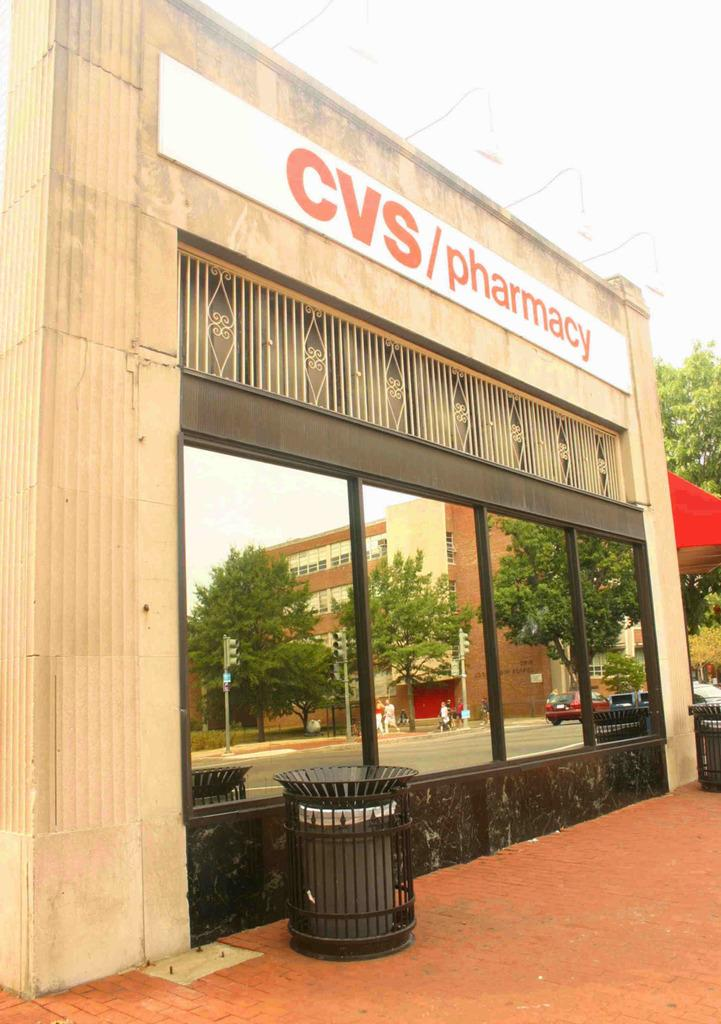<image>
Create a compact narrative representing the image presented. The front of a CVS with very clean windows 